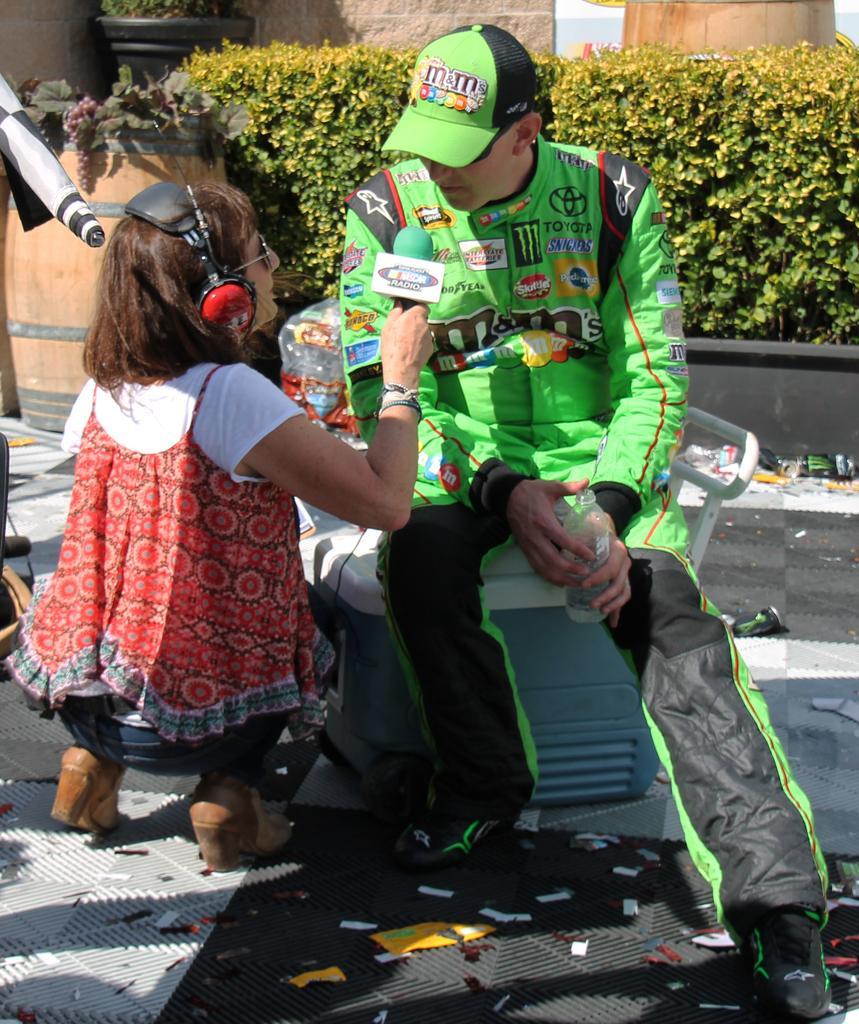How would you summarize this image in a sentence or two? In the image there is a woman sitting on road holding mic in front of man in green jersey and green cap, behind them there are plants in front of the building. 